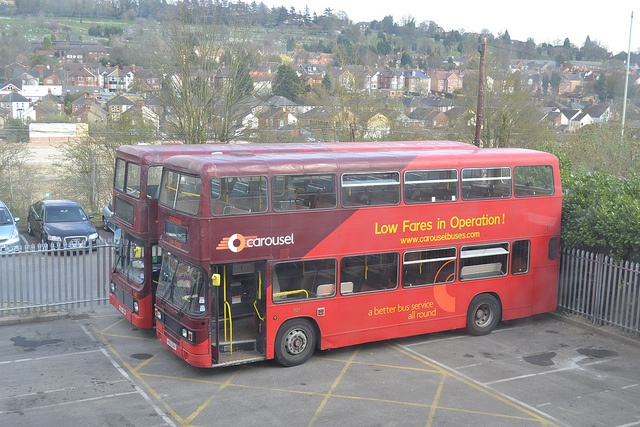Describe the objects in this image and their specific colors. I can see bus in lightgray, gray, salmon, brown, and darkgray tones, bus in lightgray, gray, lavender, darkgray, and pink tones, car in lightgray, gray, and darkgray tones, car in lightgray, lightblue, white, and gray tones, and car in lightgray, gray, and darkgray tones in this image. 